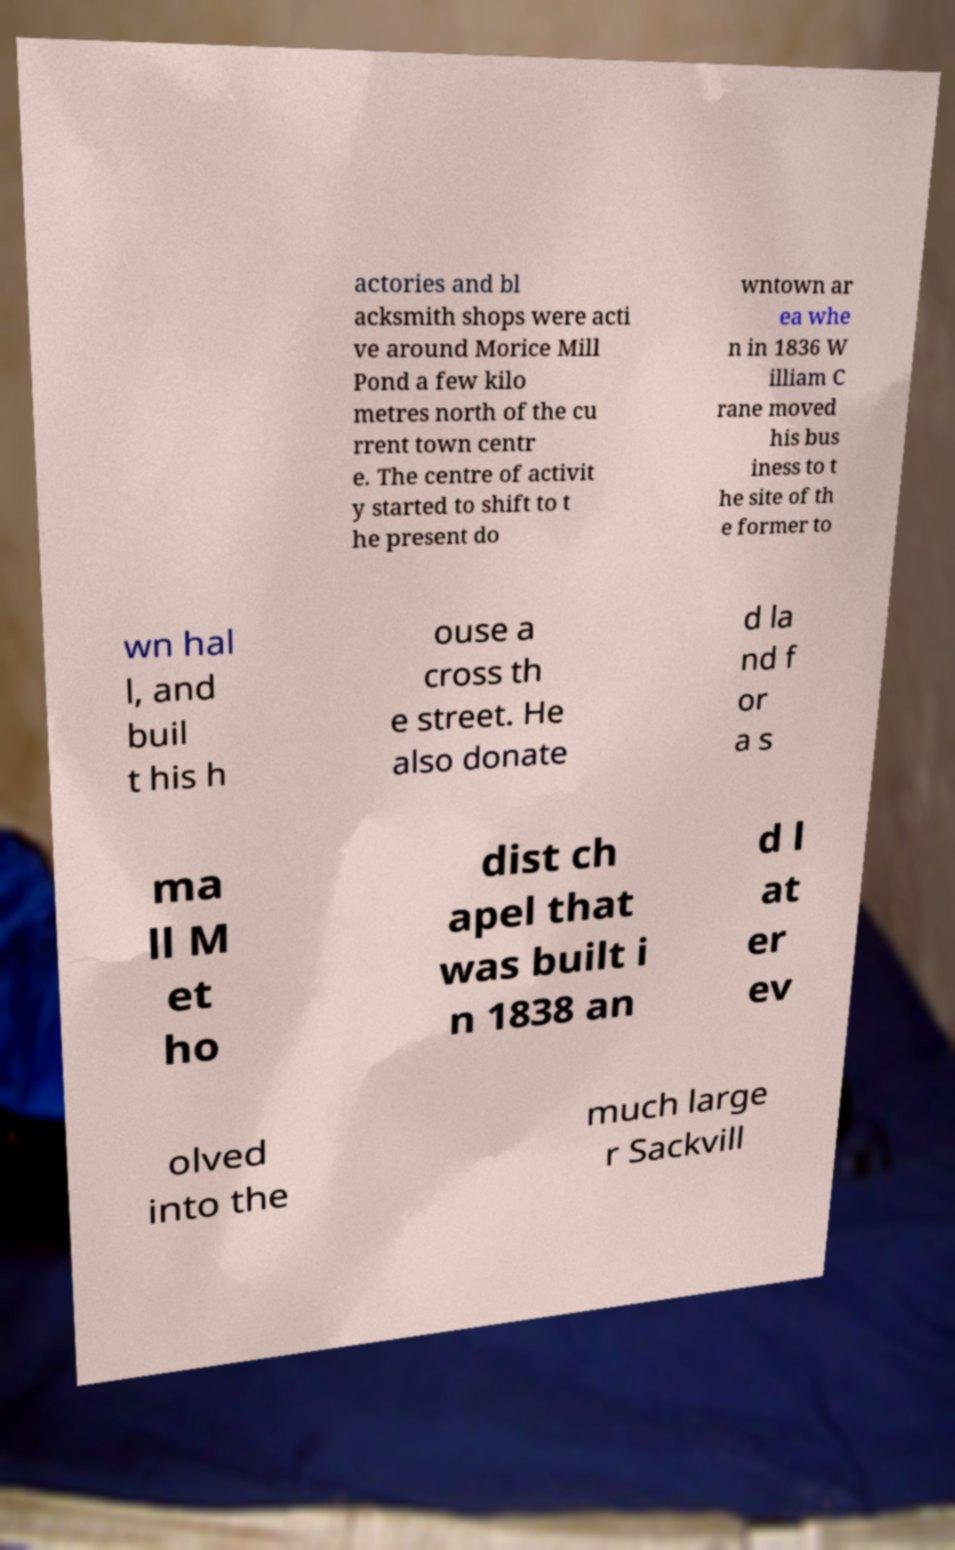For documentation purposes, I need the text within this image transcribed. Could you provide that? actories and bl acksmith shops were acti ve around Morice Mill Pond a few kilo metres north of the cu rrent town centr e. The centre of activit y started to shift to t he present do wntown ar ea whe n in 1836 W illiam C rane moved his bus iness to t he site of th e former to wn hal l, and buil t his h ouse a cross th e street. He also donate d la nd f or a s ma ll M et ho dist ch apel that was built i n 1838 an d l at er ev olved into the much large r Sackvill 